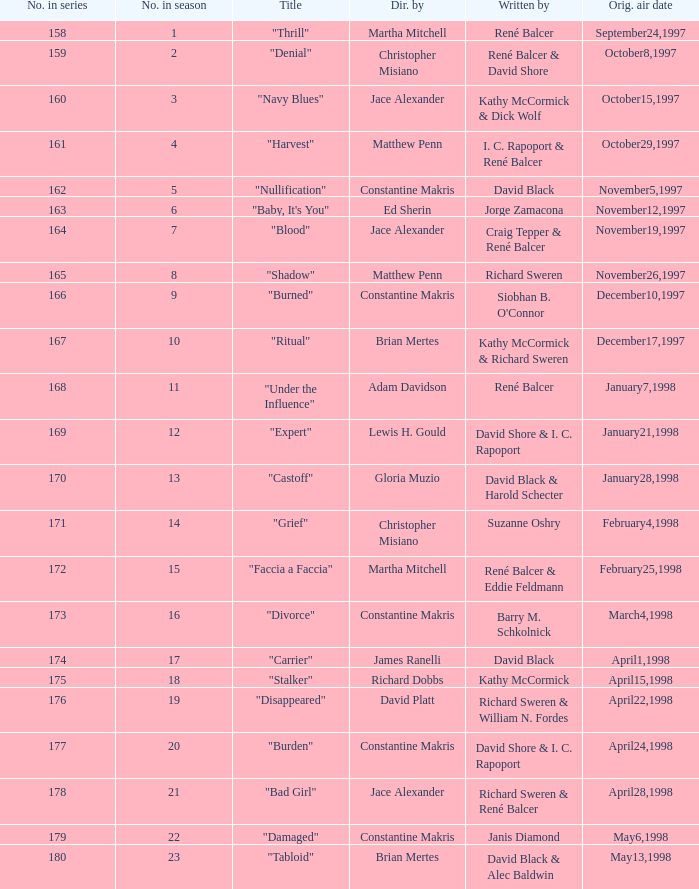The first episode in this season had what number in the series?  158.0. 